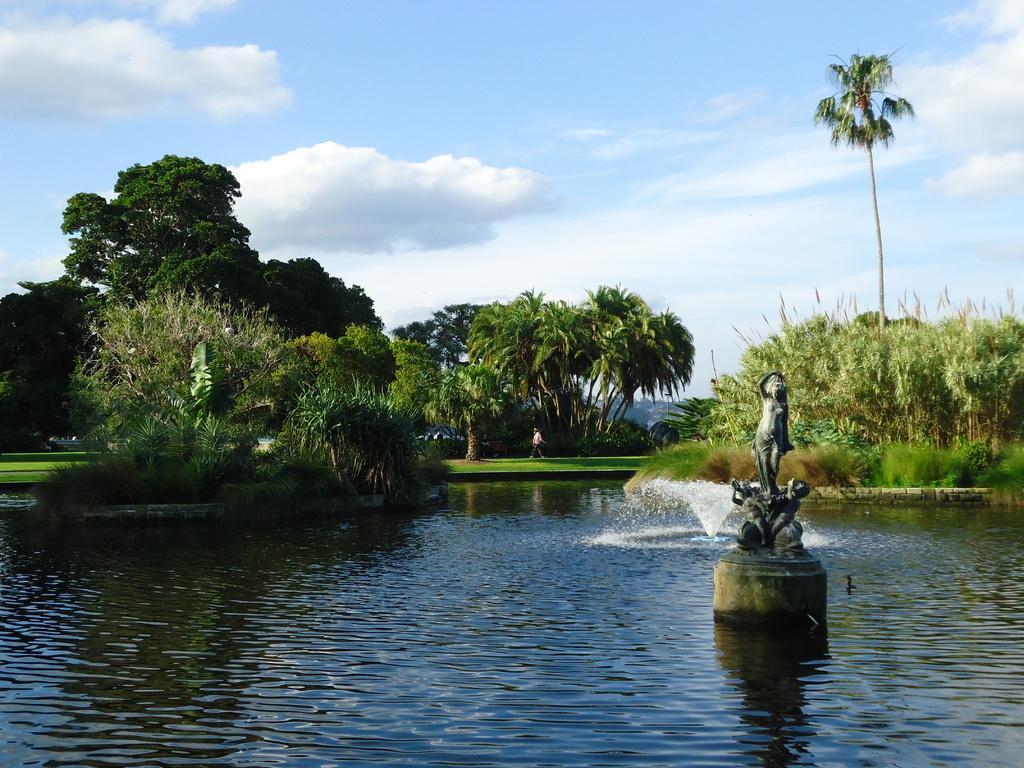Can you describe this image briefly? In this image I can see water and in it I can see a sculpture. I can also see water fountain over there. In the background I can see trees, clouds, sky and I can see a person is standing over there. 